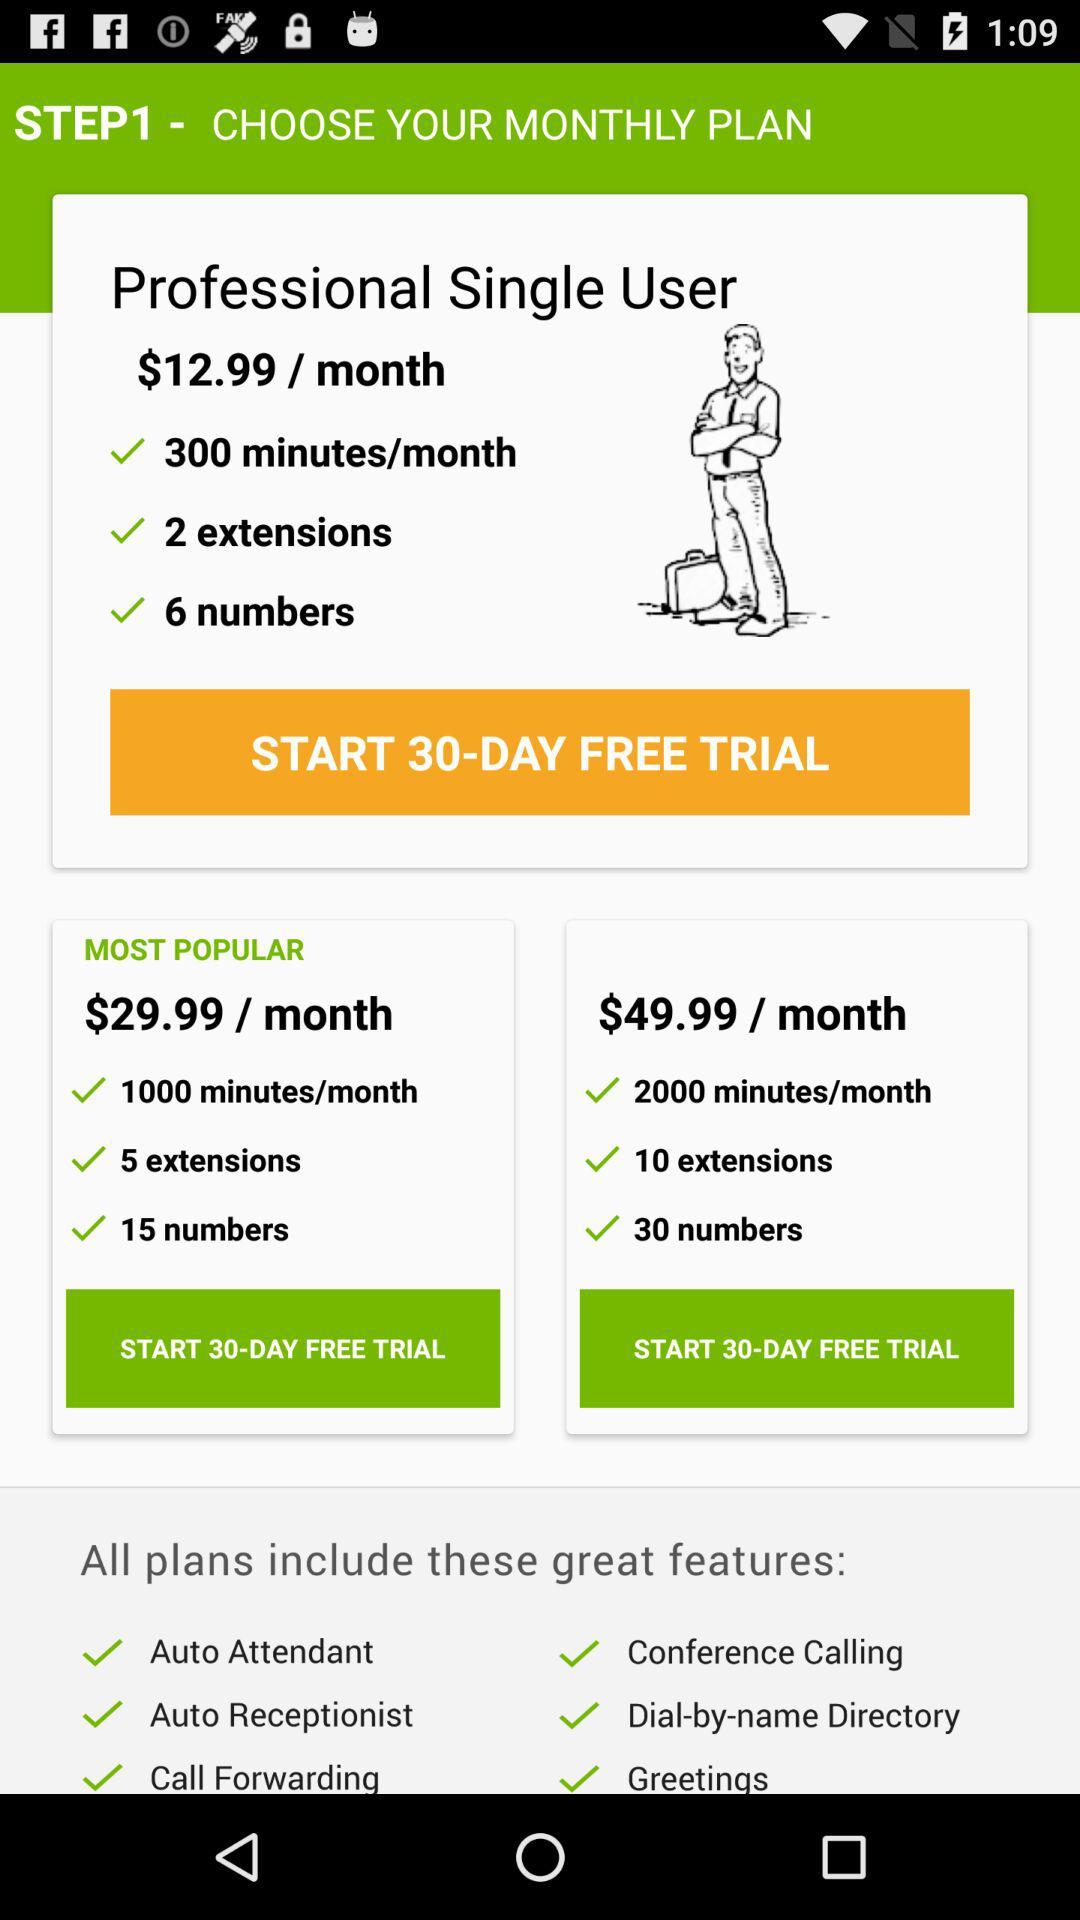Which plan has 2000 minutes per month? The plan that has 2000 minutes per month is $49.99. 